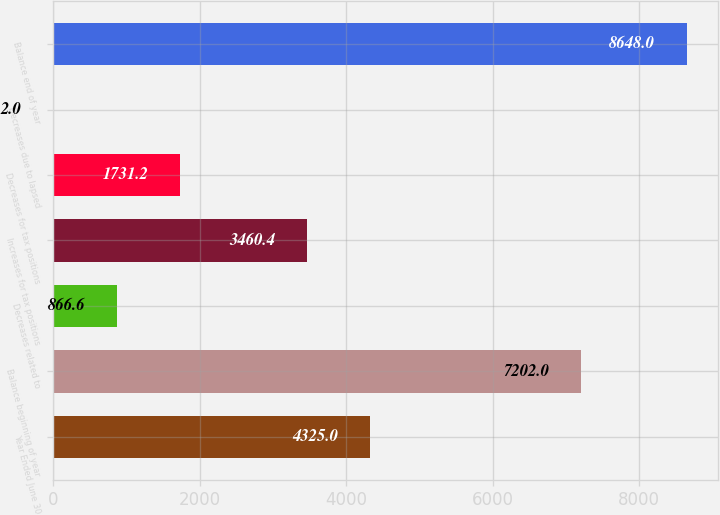Convert chart to OTSL. <chart><loc_0><loc_0><loc_500><loc_500><bar_chart><fcel>Year Ended June 30<fcel>Balance beginning of year<fcel>Decreases related to<fcel>Increases for tax positions<fcel>Decreases for tax positions<fcel>Decreases due to lapsed<fcel>Balance end of year<nl><fcel>4325<fcel>7202<fcel>866.6<fcel>3460.4<fcel>1731.2<fcel>2<fcel>8648<nl></chart> 